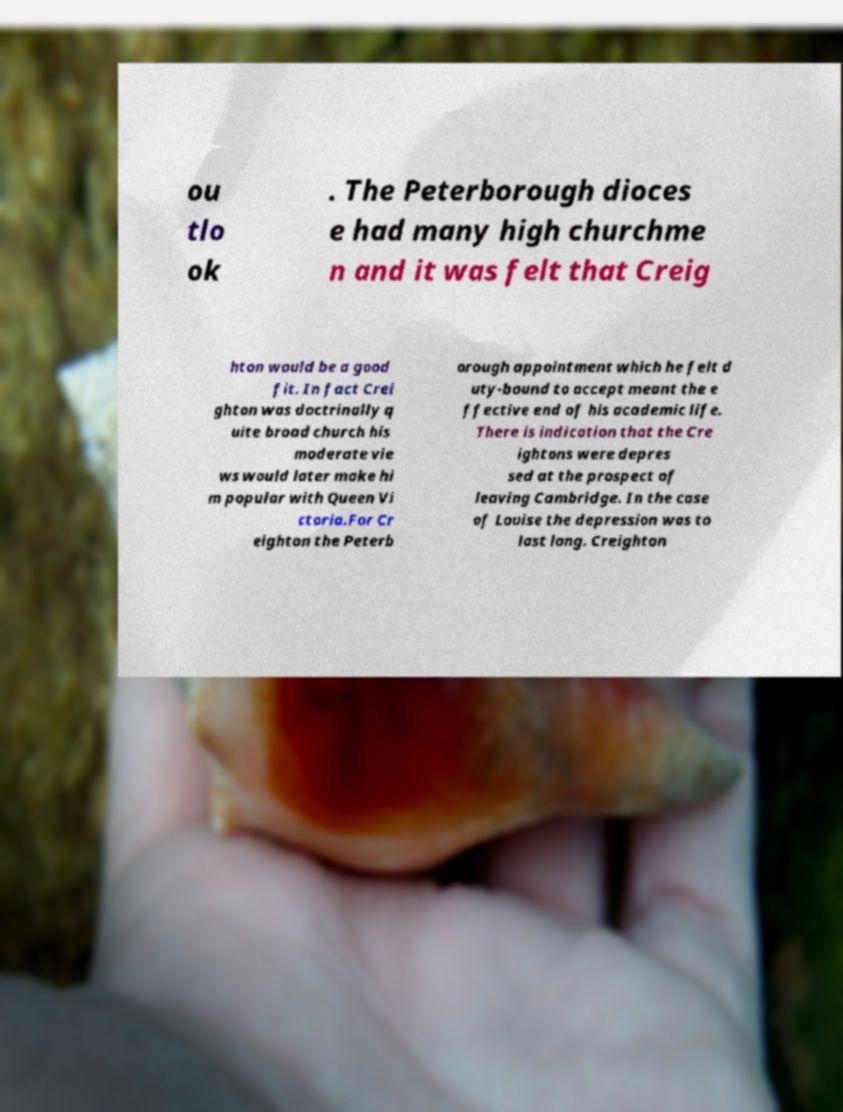There's text embedded in this image that I need extracted. Can you transcribe it verbatim? ou tlo ok . The Peterborough dioces e had many high churchme n and it was felt that Creig hton would be a good fit. In fact Crei ghton was doctrinally q uite broad church his moderate vie ws would later make hi m popular with Queen Vi ctoria.For Cr eighton the Peterb orough appointment which he felt d uty-bound to accept meant the e ffective end of his academic life. There is indication that the Cre ightons were depres sed at the prospect of leaving Cambridge. In the case of Louise the depression was to last long. Creighton 